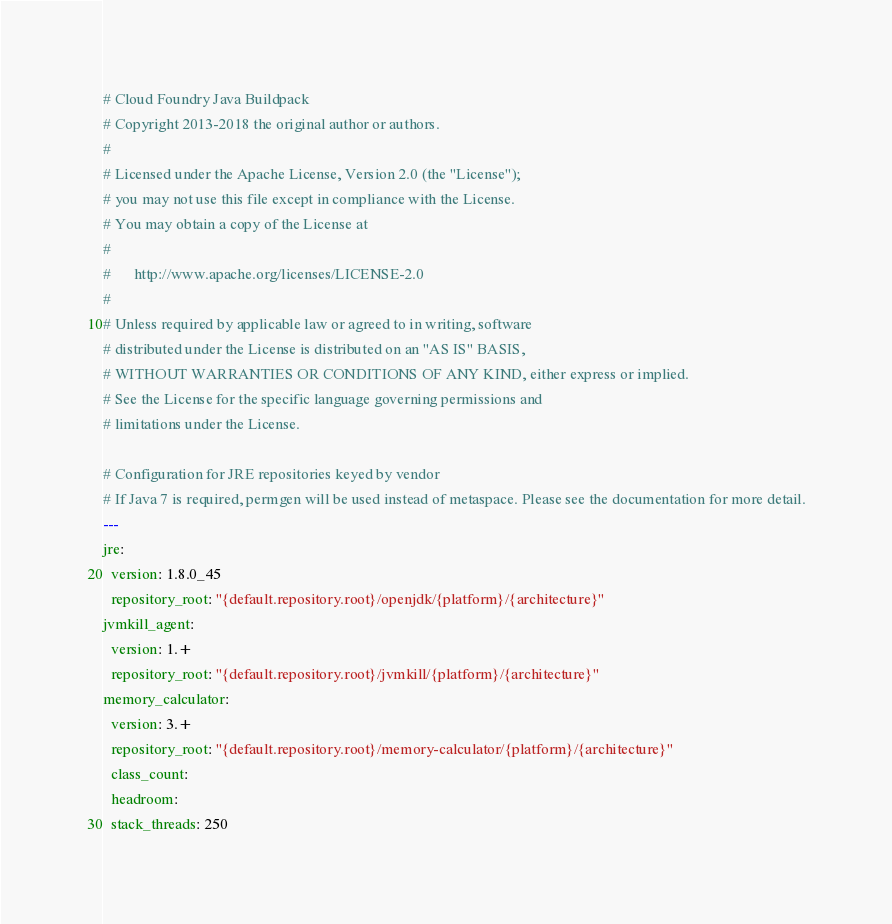<code> <loc_0><loc_0><loc_500><loc_500><_YAML_># Cloud Foundry Java Buildpack
# Copyright 2013-2018 the original author or authors.
#
# Licensed under the Apache License, Version 2.0 (the "License");
# you may not use this file except in compliance with the License.
# You may obtain a copy of the License at
#
#      http://www.apache.org/licenses/LICENSE-2.0
#
# Unless required by applicable law or agreed to in writing, software
# distributed under the License is distributed on an "AS IS" BASIS,
# WITHOUT WARRANTIES OR CONDITIONS OF ANY KIND, either express or implied.
# See the License for the specific language governing permissions and
# limitations under the License.

# Configuration for JRE repositories keyed by vendor
# If Java 7 is required, permgen will be used instead of metaspace. Please see the documentation for more detail.
---
jre:
  version: 1.8.0_45
  repository_root: "{default.repository.root}/openjdk/{platform}/{architecture}"
jvmkill_agent:
  version: 1.+
  repository_root: "{default.repository.root}/jvmkill/{platform}/{architecture}"
memory_calculator:
  version: 3.+
  repository_root: "{default.repository.root}/memory-calculator/{platform}/{architecture}"
  class_count: 
  headroom: 
  stack_threads: 250
</code> 